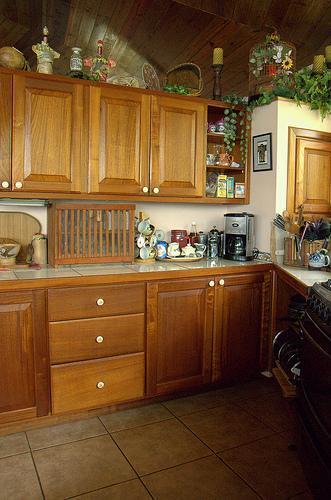How many knobs are there?
Give a very brief answer. 9. 